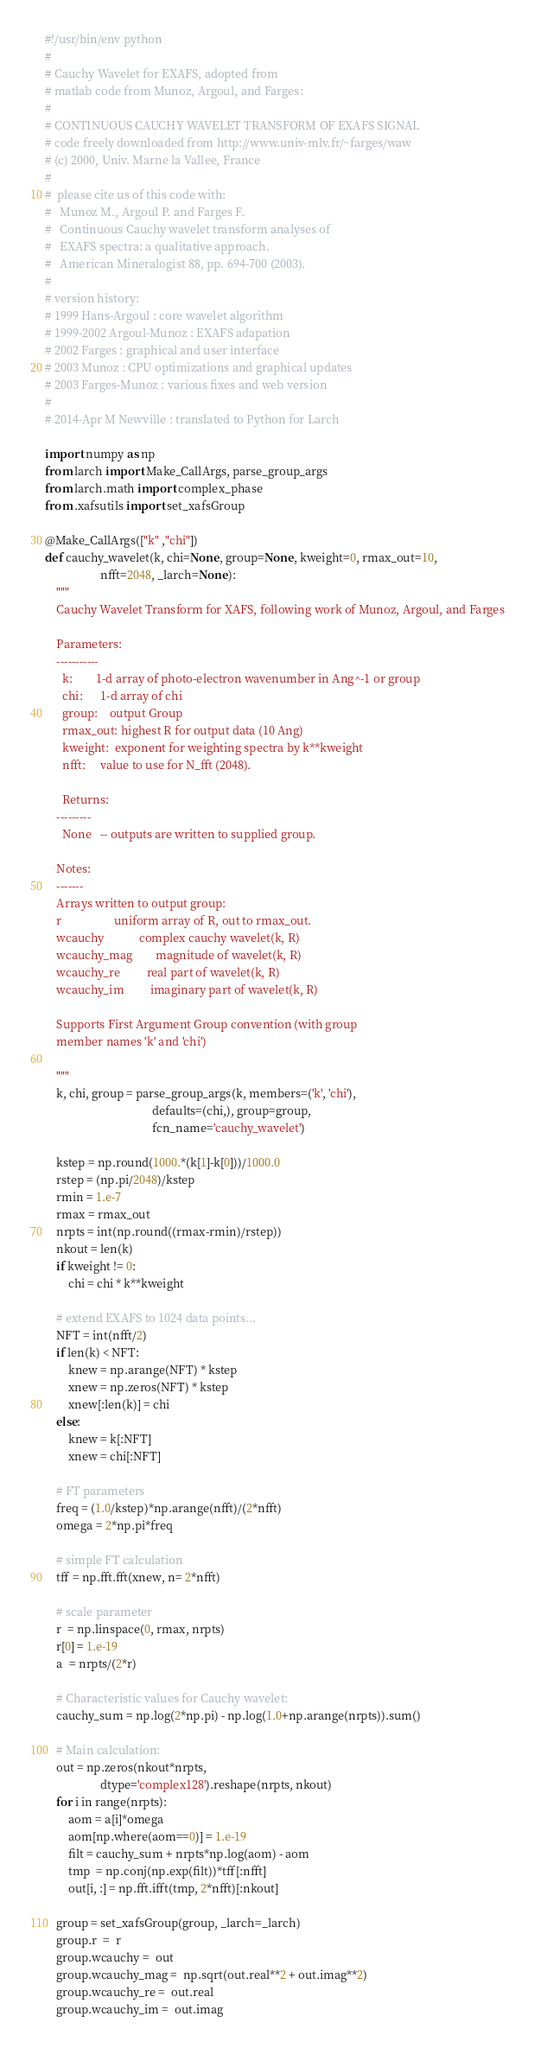<code> <loc_0><loc_0><loc_500><loc_500><_Python_>#!/usr/bin/env python
#
# Cauchy Wavelet for EXAFS, adopted from
# matlab code from Munoz, Argoul, and Farges:
#
# CONTINUOUS CAUCHY WAVELET TRANSFORM OF EXAFS SIGNAL
# code freely downloaded from http://www.univ-mlv.fr/~farges/waw
# (c) 2000, Univ. Marne la Vallee, France
#
#  please cite us of this code with:
#   Munoz M., Argoul P. and Farges F.
#   Continuous Cauchy wavelet transform analyses of
#   EXAFS spectra: a qualitative approach.
#   American Mineralogist 88, pp. 694-700 (2003).
#
# version history:
# 1999 Hans-Argoul : core wavelet algorithm
# 1999-2002 Argoul-Munoz : EXAFS adapation
# 2002 Farges : graphical and user interface
# 2003 Munoz : CPU optimizations and graphical updates
# 2003 Farges-Munoz : various fixes and web version
#
# 2014-Apr M Newville : translated to Python for Larch

import numpy as np
from larch import Make_CallArgs, parse_group_args
from larch.math import complex_phase
from .xafsutils import set_xafsGroup

@Make_CallArgs(["k" ,"chi"])
def cauchy_wavelet(k, chi=None, group=None, kweight=0, rmax_out=10,
                   nfft=2048, _larch=None):
    """
    Cauchy Wavelet Transform for XAFS, following work of Munoz, Argoul, and Farges

    Parameters:
    -----------
      k:        1-d array of photo-electron wavenumber in Ang^-1 or group
      chi:      1-d array of chi
      group:    output Group
      rmax_out: highest R for output data (10 Ang)
      kweight:  exponent for weighting spectra by k**kweight
      nfft:     value to use for N_fft (2048).

      Returns:
    ---------
      None   -- outputs are written to supplied group.

    Notes:
    -------
    Arrays written to output group:
    r                  uniform array of R, out to rmax_out.
    wcauchy            complex cauchy wavelet(k, R)
    wcauchy_mag        magnitude of wavelet(k, R)
    wcauchy_re         real part of wavelet(k, R)
    wcauchy_im         imaginary part of wavelet(k, R)

    Supports First Argument Group convention (with group
    member names 'k' and 'chi')

    """
    k, chi, group = parse_group_args(k, members=('k', 'chi'),
                                     defaults=(chi,), group=group,
                                     fcn_name='cauchy_wavelet')

    kstep = np.round(1000.*(k[1]-k[0]))/1000.0
    rstep = (np.pi/2048)/kstep
    rmin = 1.e-7
    rmax = rmax_out
    nrpts = int(np.round((rmax-rmin)/rstep))
    nkout = len(k)
    if kweight != 0:
        chi = chi * k**kweight

    # extend EXAFS to 1024 data points...
    NFT = int(nfft/2)
    if len(k) < NFT:
        knew = np.arange(NFT) * kstep
        xnew = np.zeros(NFT) * kstep
        xnew[:len(k)] = chi
    else:
        knew = k[:NFT]
        xnew = chi[:NFT]

    # FT parameters
    freq = (1.0/kstep)*np.arange(nfft)/(2*nfft)
    omega = 2*np.pi*freq

    # simple FT calculation
    tff = np.fft.fft(xnew, n= 2*nfft)

    # scale parameter
    r  = np.linspace(0, rmax, nrpts)
    r[0] = 1.e-19
    a  = nrpts/(2*r)

    # Characteristic values for Cauchy wavelet:
    cauchy_sum = np.log(2*np.pi) - np.log(1.0+np.arange(nrpts)).sum()

    # Main calculation:
    out = np.zeros(nkout*nrpts,
                   dtype='complex128').reshape(nrpts, nkout)
    for i in range(nrpts):
        aom = a[i]*omega
        aom[np.where(aom==0)] = 1.e-19
        filt = cauchy_sum + nrpts*np.log(aom) - aom
        tmp  = np.conj(np.exp(filt))*tff[:nfft]
        out[i, :] = np.fft.ifft(tmp, 2*nfft)[:nkout]

    group = set_xafsGroup(group, _larch=_larch)
    group.r  =  r
    group.wcauchy =  out
    group.wcauchy_mag =  np.sqrt(out.real**2 + out.imag**2)
    group.wcauchy_re =  out.real
    group.wcauchy_im =  out.imag
</code> 